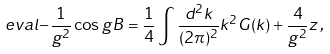Convert formula to latex. <formula><loc_0><loc_0><loc_500><loc_500>\ e v a l { - \frac { 1 } { g ^ { 2 } } \cos g B } = \frac { 1 } { 4 } \int \frac { d ^ { 2 } k } { ( 2 \pi ) ^ { 2 } } k ^ { 2 } G ( k ) + \frac { 4 } { g ^ { 2 } } z \, ,</formula> 